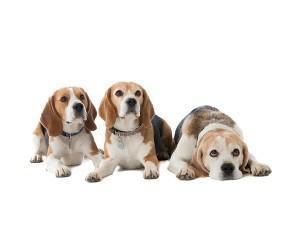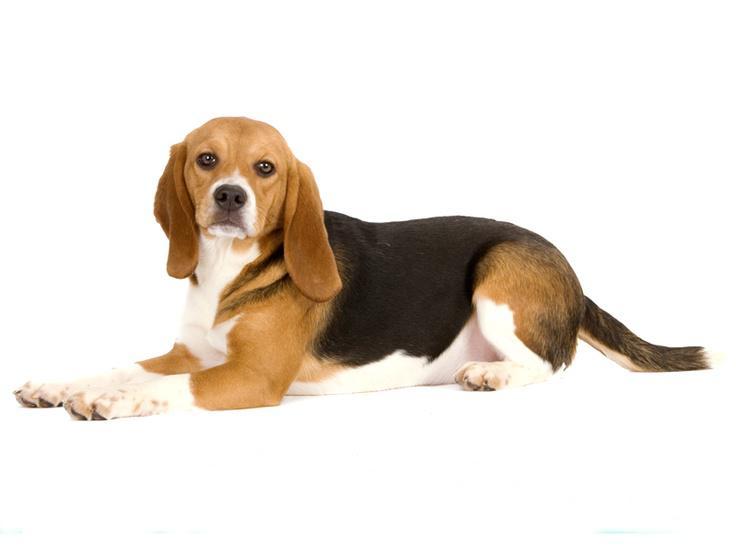The first image is the image on the left, the second image is the image on the right. Given the left and right images, does the statement "There are three dogs in each of the images." hold true? Answer yes or no. No. 